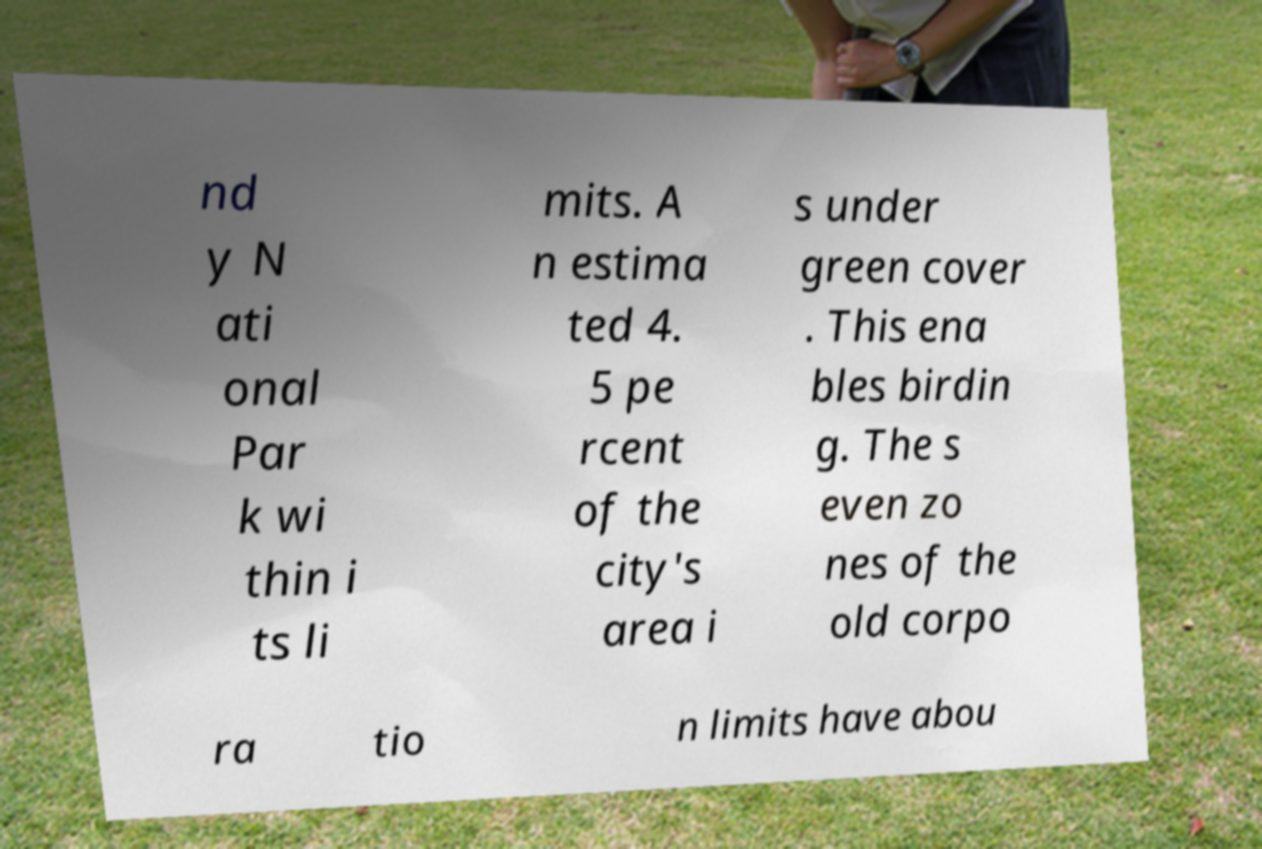Please read and relay the text visible in this image. What does it say? nd y N ati onal Par k wi thin i ts li mits. A n estima ted 4. 5 pe rcent of the city's area i s under green cover . This ena bles birdin g. The s even zo nes of the old corpo ra tio n limits have abou 